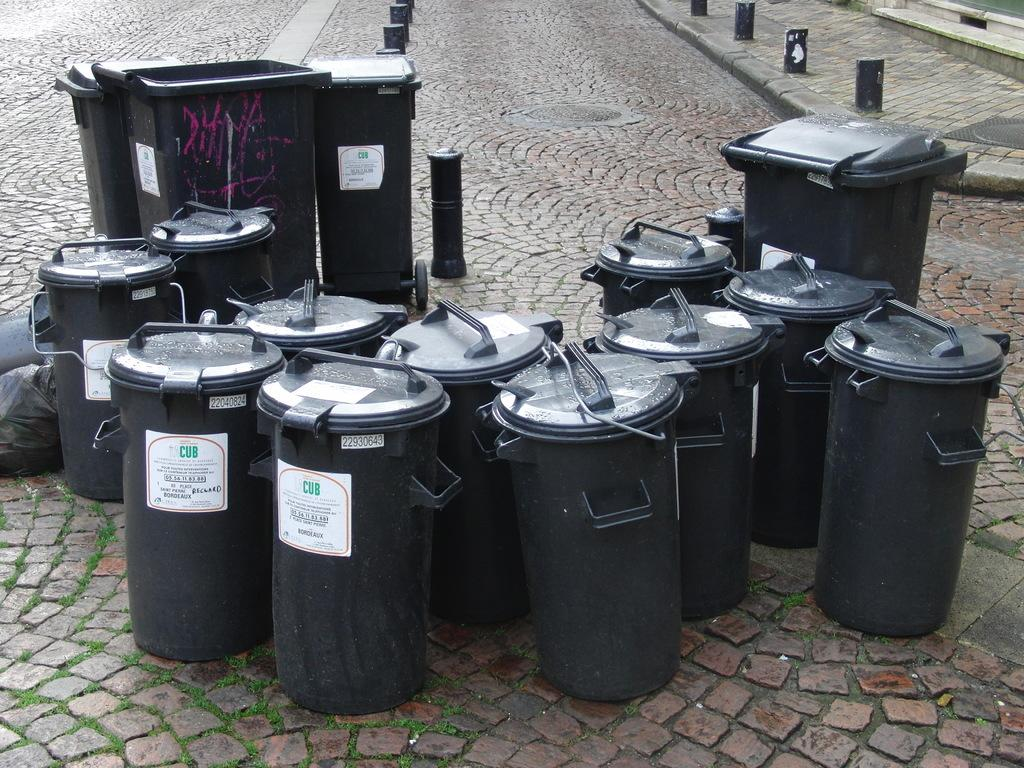<image>
Present a compact description of the photo's key features. A bunch of  containers with CUB on the label are on a brick pavement. 